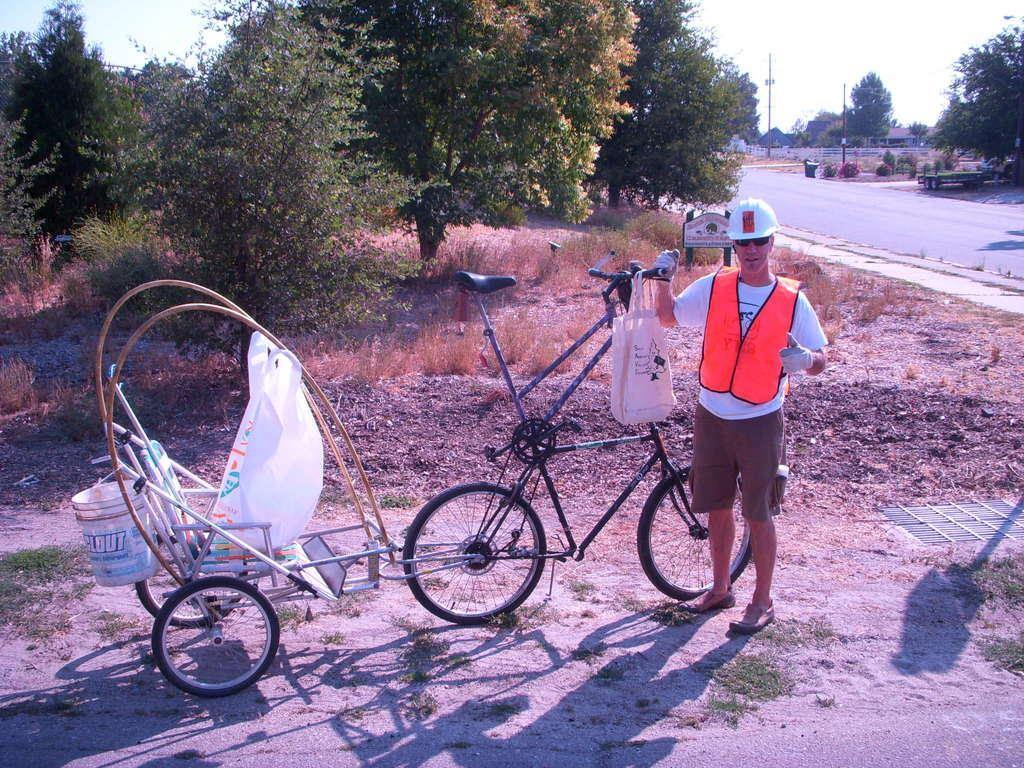How would you summarize this image in a sentence or two? There is one person standing at the bottom of this image is holding a bicycle. There are some trees in the background. There is a road on the right side of this image. 